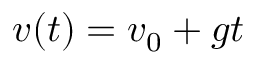<formula> <loc_0><loc_0><loc_500><loc_500>v ( t ) = v _ { 0 } + g t</formula> 